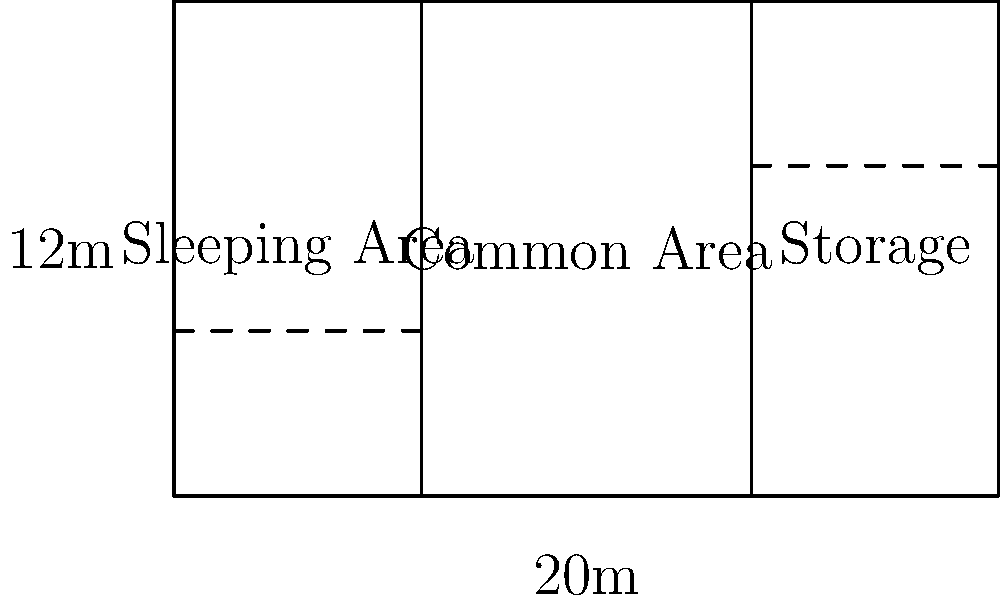A refugee shelter has a rectangular floor plan as shown in the diagram. The shelter is divided into three sections: sleeping area, common area, and storage. If each person requires a minimum of 3.5 square meters in the sleeping area, what is the maximum number of refugees this shelter can accommodate? To solve this problem, we need to follow these steps:

1. Calculate the total area of the shelter:
   Length = 20 m, Width = 12 m
   Total area = $20 \text{ m} \times 12 \text{ m} = 240 \text{ m}^2$

2. Determine the area of the sleeping section:
   The sleeping area occupies 3/10 of the total width.
   Sleeping area width = $3/10 \times 20 \text{ m} = 6 \text{ m}$
   Sleeping area = $6 \text{ m} \times 12 \text{ m} = 72 \text{ m}^2$

3. Calculate the number of refugees that can be accommodated:
   Each person requires 3.5 square meters.
   Number of refugees = $72 \text{ m}^2 \div 3.5 \text{ m}^2/\text{person} = 20.57$

4. Round down to the nearest whole number, as we can't accommodate partial people.

Therefore, the maximum number of refugees this shelter can accommodate is 20.
Answer: 20 refugees 